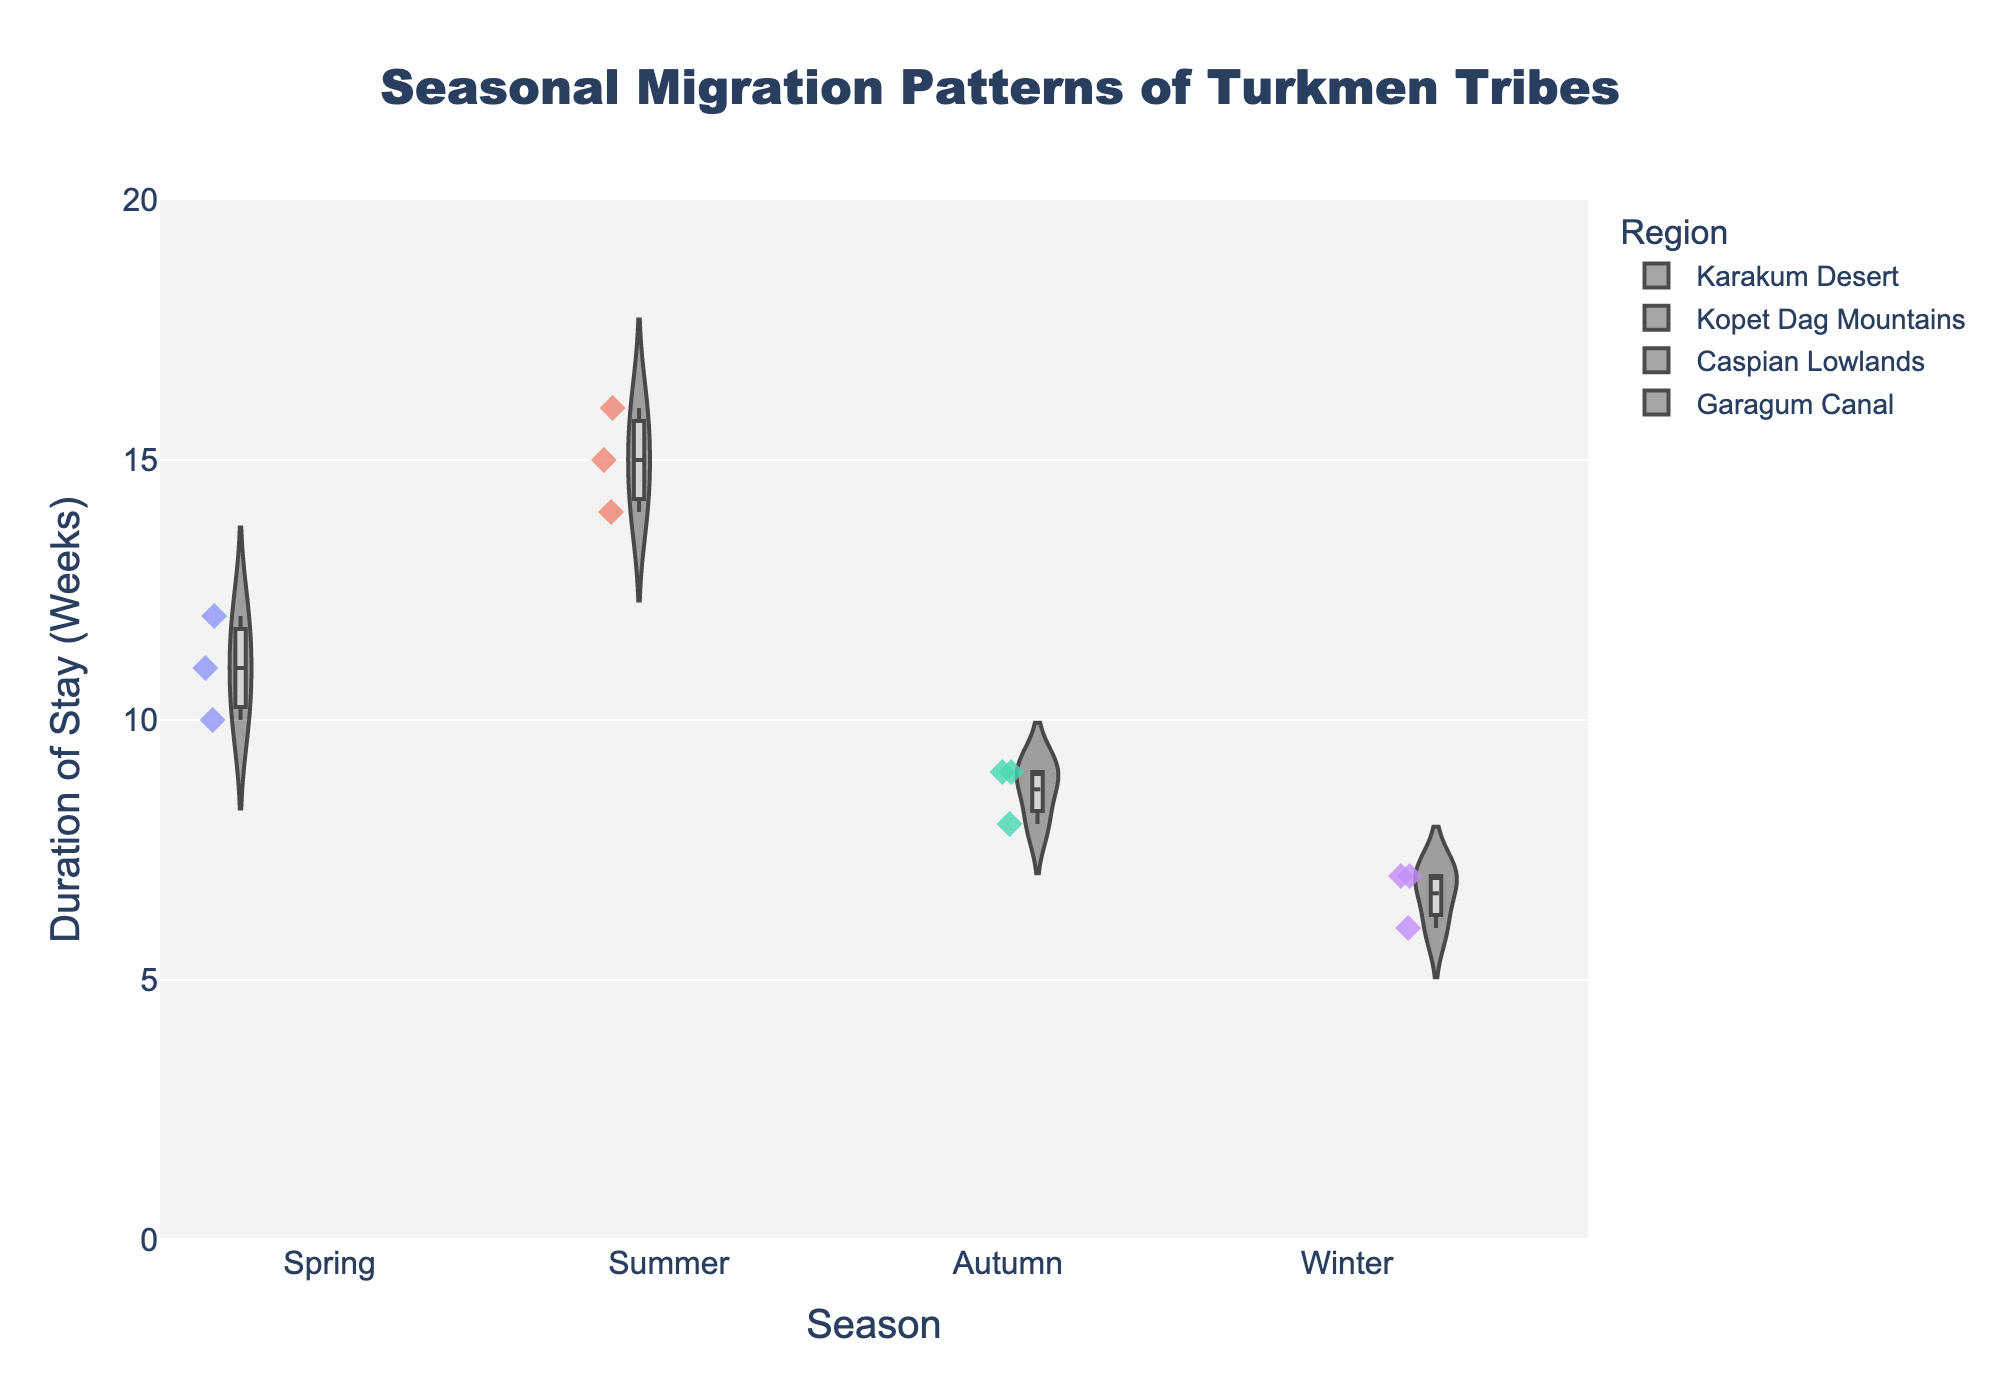What is the title of the plot? Look at the top of the plot where the title is clearly displayed in bold font.
Answer: "Seasonal Migration Patterns of Turkmen Tribes" Which season has the longest average duration of stay? Compare the average duration of stay indicated by the mean line for each season. The summer season violin plot has a higher average.
Answer: Summer How do the durations of stay in the spring differ across different regions? Look at the distribution within the Spring violin plots categorized by regions (Karakum Desert). The durations in Ahal are around 10 weeks, Mary around 12 weeks, and Balkan around 11 weeks.
Answer: Ahal: 10 weeks, Mary: 12 weeks, Balkan: 11 weeks Which region shows the smallest variability in the duration of stay across all seasons? Compare the spread (width) of the violin plots for each region. The Caspian Lowlands violin plots have the most consistent width, suggesting the smallest variability.
Answer: Caspian Lowlands In which season does the Garagum Canal region show the most varied duration of stay? Observe the spread of the violin plots for the Garagum Canal across all seasons. The Winter season for Garagum Canal shows a slightly wider spread, indicating more variability.
Answer: Winter What is the range of stay duration for the Ahal region in the Summer season? Check the Ahal region's violin plot for the Summer season and observe the spread from the bottom to the top. The duration ranges from about 13 to 15 weeks.
Answer: 13-15 weeks How many data points are included in the Winter season plots? Add up the data points marked as "Winter" in the image. Each region in Winter (Garagum Canal) has 3 data points, totaling 9 data points.
Answer: 9 Which season has the shortest maximum duration of stay and what is it? Look at the uppermost point of the violin plots for each season. Autumn has the shortest maximum duration, around 9 weeks.
Answer: Autumn, 9 weeks 